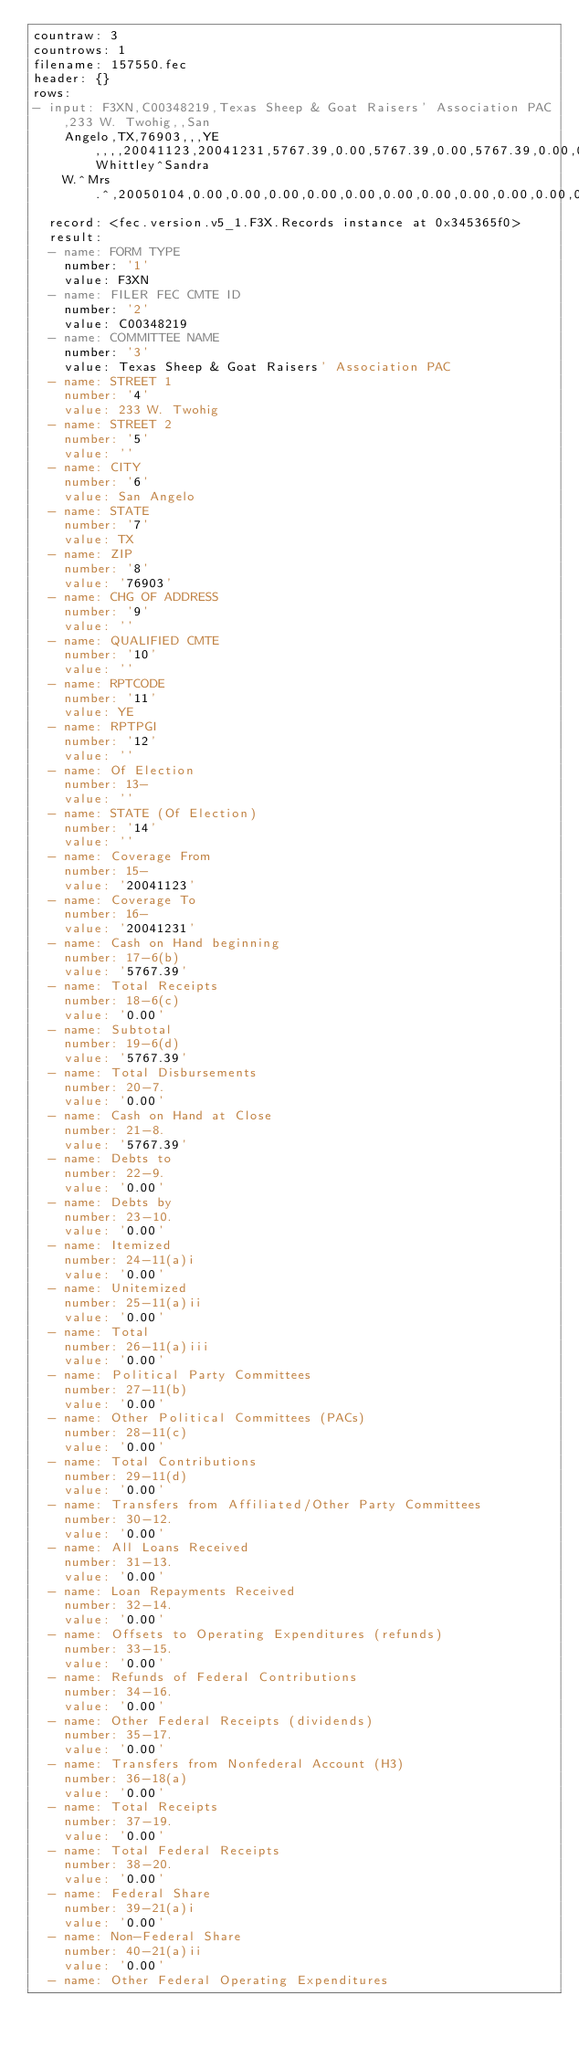<code> <loc_0><loc_0><loc_500><loc_500><_YAML_>countraw: 3
countrows: 1
filename: 157550.fec
header: {}
rows:
- input: F3XN,C00348219,Texas Sheep & Goat Raisers' Association PAC,233 W. Twohig,,San
    Angelo,TX,76903,,,YE,,,,20041123,20041231,5767.39,0.00,5767.39,0.00,5767.39,0.00,0.00,0.00,0.00,0.00,0.00,0.00,0.00,0.00,0.00,0.00,0.00,0.00,0.00,0.00,0.00,0.00,0.00,0.00,0.00,0.00,0.00,0.00,0.00,0.00,0.00,0.00,0.00,0.00,0.00,0.00,0.00,0.00,0.00,0.00,0.00,0.00,0.00,0.00,0.00,3867.39,2004,2900.00,6767.39,1000.00,5767.39,1750.00,1150.00,2900.00,0.00,0.00,2900.00,0.00,0.00,0.00,0.00,0.00,0.00,0.00,2900.00,2900.00,0.00,0.00,0.00,0.00,0.00,1000.00,0.00,0.00,0.00,0.00,0.00,0.00,0.00,0.00,0.00,1000.00,1000.00,2900.00,0.00,2900.00,0.00,0.00,0.00,Whittley^Sandra
    W.^Mrs.^,20050104,0.00,0.00,0.00,0.00,0.00,0.00,0.00,0.00,0.00,0.00,0.00,0.00
  record: <fec.version.v5_1.F3X.Records instance at 0x345365f0>
  result:
  - name: FORM TYPE
    number: '1'
    value: F3XN
  - name: FILER FEC CMTE ID
    number: '2'
    value: C00348219
  - name: COMMITTEE NAME
    number: '3'
    value: Texas Sheep & Goat Raisers' Association PAC
  - name: STREET 1
    number: '4'
    value: 233 W. Twohig
  - name: STREET 2
    number: '5'
    value: ''
  - name: CITY
    number: '6'
    value: San Angelo
  - name: STATE
    number: '7'
    value: TX
  - name: ZIP
    number: '8'
    value: '76903'
  - name: CHG OF ADDRESS
    number: '9'
    value: ''
  - name: QUALIFIED CMTE
    number: '10'
    value: ''
  - name: RPTCODE
    number: '11'
    value: YE
  - name: RPTPGI
    number: '12'
    value: ''
  - name: Of Election
    number: 13-
    value: ''
  - name: STATE (Of Election)
    number: '14'
    value: ''
  - name: Coverage From
    number: 15-
    value: '20041123'
  - name: Coverage To
    number: 16-
    value: '20041231'
  - name: Cash on Hand beginning
    number: 17-6(b)
    value: '5767.39'
  - name: Total Receipts
    number: 18-6(c)
    value: '0.00'
  - name: Subtotal
    number: 19-6(d)
    value: '5767.39'
  - name: Total Disbursements
    number: 20-7.
    value: '0.00'
  - name: Cash on Hand at Close
    number: 21-8.
    value: '5767.39'
  - name: Debts to
    number: 22-9.
    value: '0.00'
  - name: Debts by
    number: 23-10.
    value: '0.00'
  - name: Itemized
    number: 24-11(a)i
    value: '0.00'
  - name: Unitemized
    number: 25-11(a)ii
    value: '0.00'
  - name: Total
    number: 26-11(a)iii
    value: '0.00'
  - name: Political Party Committees
    number: 27-11(b)
    value: '0.00'
  - name: Other Political Committees (PACs)
    number: 28-11(c)
    value: '0.00'
  - name: Total Contributions
    number: 29-11(d)
    value: '0.00'
  - name: Transfers from Affiliated/Other Party Committees
    number: 30-12.
    value: '0.00'
  - name: All Loans Received
    number: 31-13.
    value: '0.00'
  - name: Loan Repayments Received
    number: 32-14.
    value: '0.00'
  - name: Offsets to Operating Expenditures (refunds)
    number: 33-15.
    value: '0.00'
  - name: Refunds of Federal Contributions
    number: 34-16.
    value: '0.00'
  - name: Other Federal Receipts (dividends)
    number: 35-17.
    value: '0.00'
  - name: Transfers from Nonfederal Account (H3)
    number: 36-18(a)
    value: '0.00'
  - name: Total Receipts
    number: 37-19.
    value: '0.00'
  - name: Total Federal Receipts
    number: 38-20.
    value: '0.00'
  - name: Federal Share
    number: 39-21(a)i
    value: '0.00'
  - name: Non-Federal Share
    number: 40-21(a)ii
    value: '0.00'
  - name: Other Federal Operating Expenditures</code> 